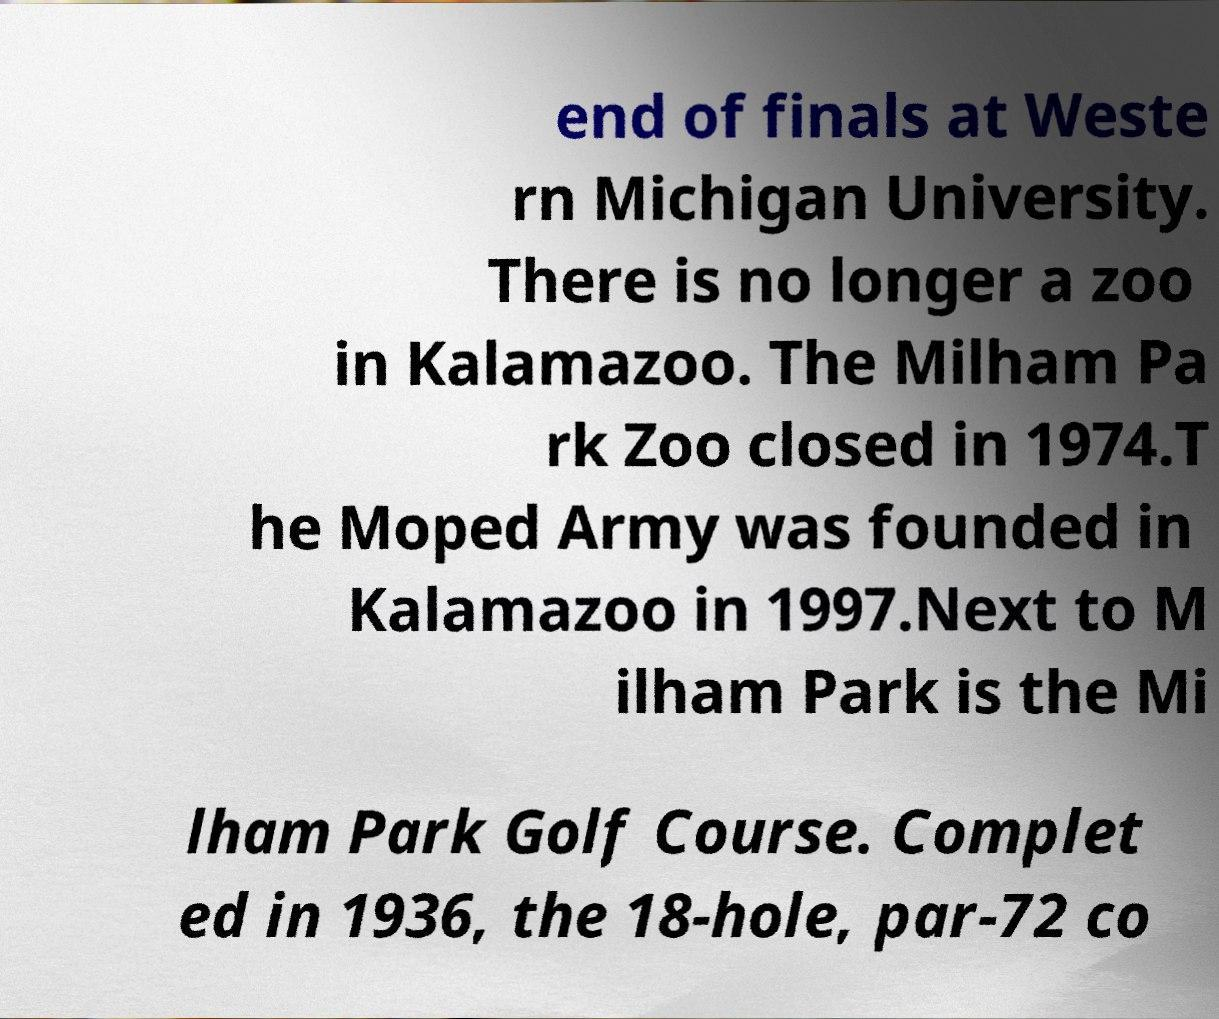For documentation purposes, I need the text within this image transcribed. Could you provide that? end of finals at Weste rn Michigan University. There is no longer a zoo in Kalamazoo. The Milham Pa rk Zoo closed in 1974.T he Moped Army was founded in Kalamazoo in 1997.Next to M ilham Park is the Mi lham Park Golf Course. Complet ed in 1936, the 18-hole, par-72 co 